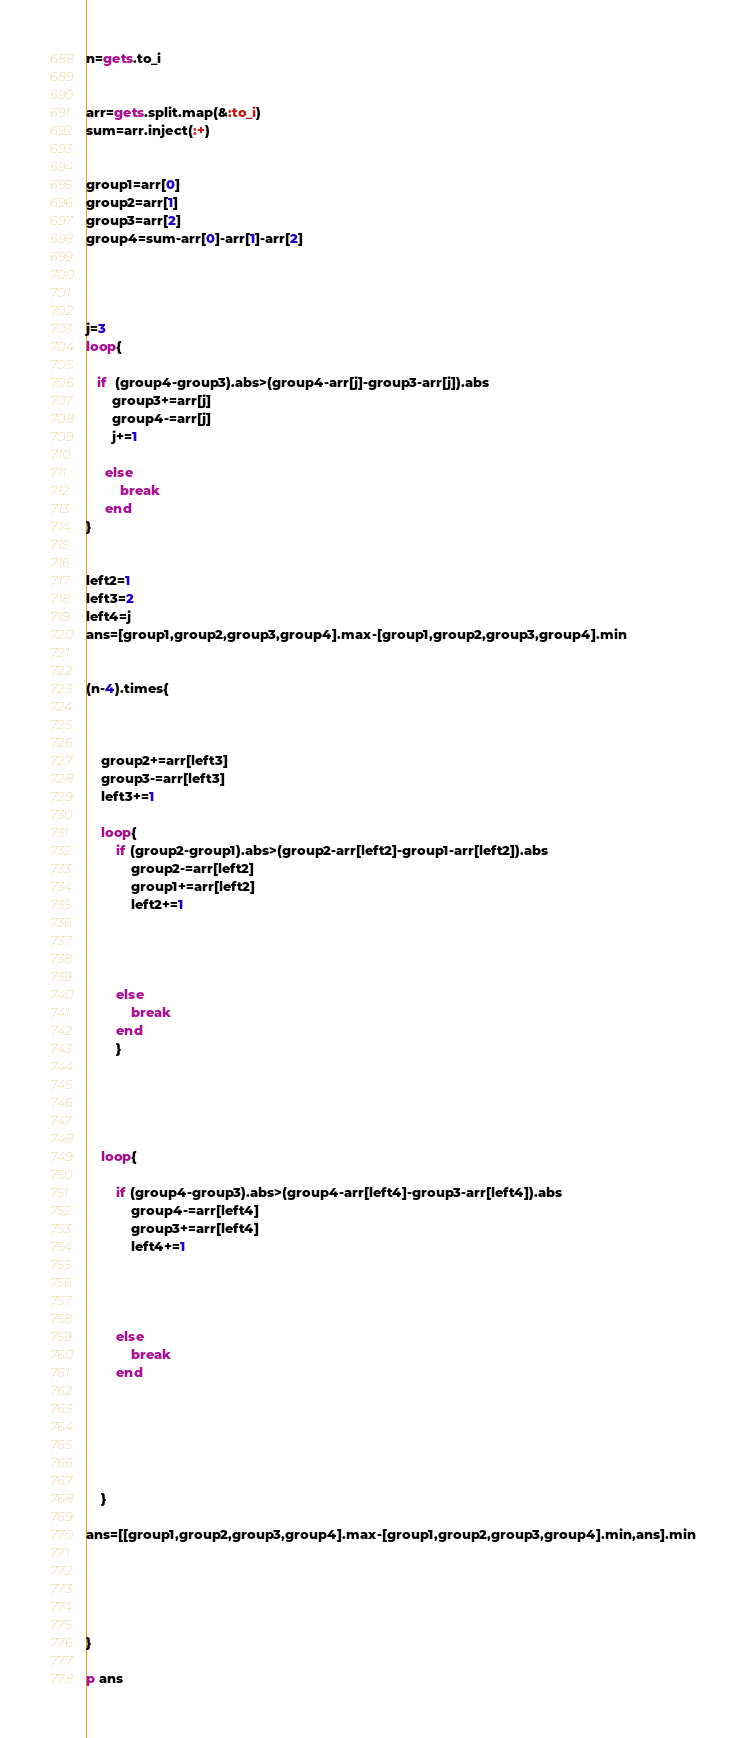<code> <loc_0><loc_0><loc_500><loc_500><_Ruby_>n=gets.to_i


arr=gets.split.map(&:to_i)
sum=arr.inject(:+)


group1=arr[0]
group2=arr[1]
group3=arr[2]
group4=sum-arr[0]-arr[1]-arr[2]




j=3
loop{
   
   if  (group4-group3).abs>(group4-arr[j]-group3-arr[j]).abs
       group3+=arr[j]
       group4-=arr[j]
       j+=1
       
     else 
         break
     end
}


left2=1
left3=2
left4=j
ans=[group1,group2,group3,group4].max-[group1,group2,group3,group4].min


(n-4).times{
    
    
    
    group2+=arr[left3]
    group3-=arr[left3]
    left3+=1
    
    loop{
        if (group2-group1).abs>(group2-arr[left2]-group1-arr[left2]).abs
            group2-=arr[left2]
            group1+=arr[left2]
            left2+=1
            
            
            
            
        else
            break
        end
        }
    
    
    
    
    
    loop{
        
        if (group4-group3).abs>(group4-arr[left4]-group3-arr[left4]).abs
            group4-=arr[left4]
            group3+=arr[left4]
            left4+=1
            
            
            
            
        else
            break
        end
        
        
        
        
        
        
    }
    
ans=[[group1,group2,group3,group4].max-[group1,group2,group3,group4].min,ans].min
    
    
    
    
    
}

p ans




</code> 